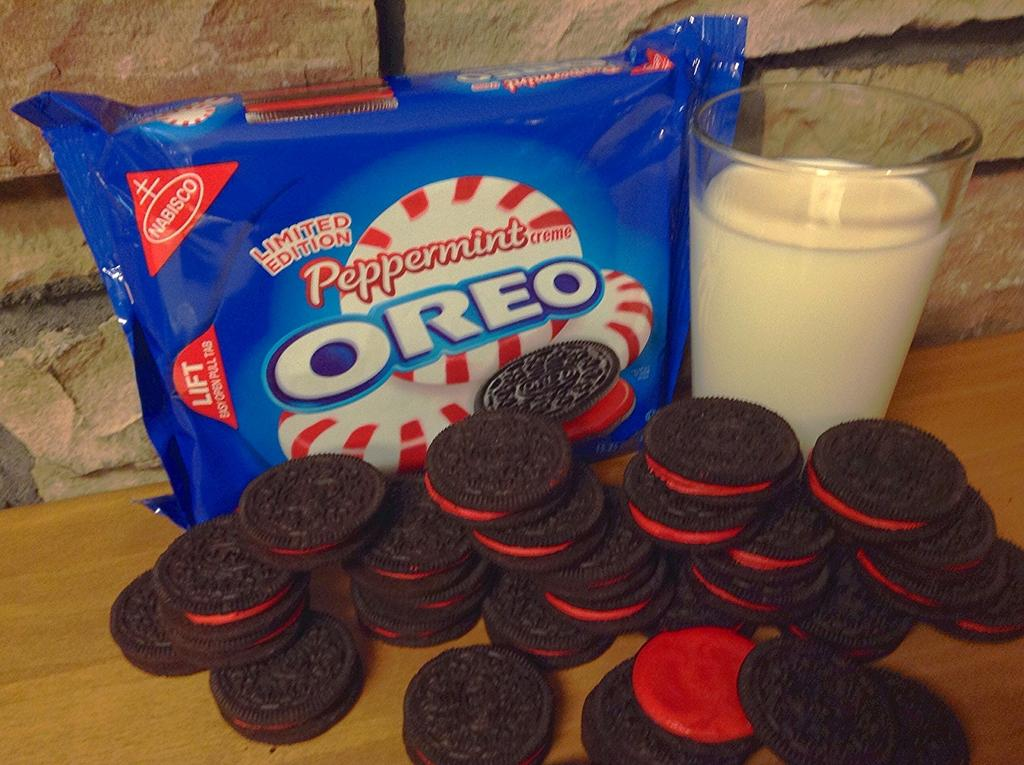What type of food can be seen in the image? There are biscuits in the image. What is the biscuits being served with? There is milk in a glass in the image. Where can the biscuits be found in the image? The biscuits are in a biscuit packet in the image. What is visible in the background of the image? There is a wall visible in the image. What type of glass is being used to express hate in the image? There is no glass being used to express hate in the image; the glass contains milk for the biscuits. 